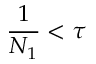<formula> <loc_0><loc_0><loc_500><loc_500>\frac { 1 } { N _ { 1 } } < \tau</formula> 